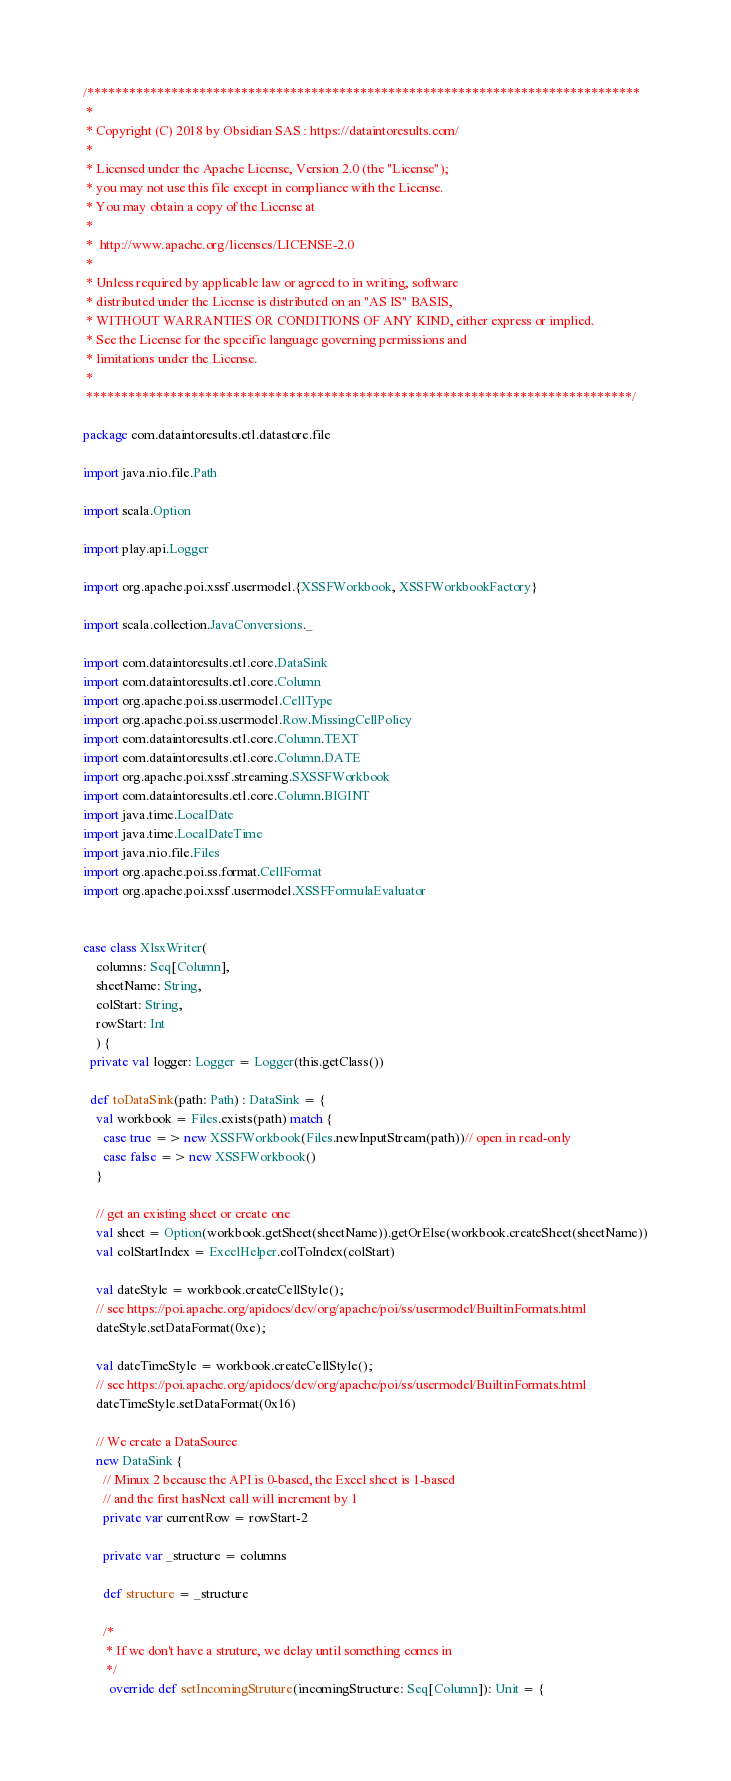Convert code to text. <code><loc_0><loc_0><loc_500><loc_500><_Scala_>/*******************************************************************************
 *
 * Copyright (C) 2018 by Obsidian SAS : https://dataintoresults.com/
 *
 * Licensed under the Apache License, Version 2.0 (the "License");
 * you may not use this file except in compliance with the License.
 * You may obtain a copy of the License at
 *
 *  http://www.apache.org/licenses/LICENSE-2.0
 *
 * Unless required by applicable law or agreed to in writing, software
 * distributed under the License is distributed on an "AS IS" BASIS,
 * WITHOUT WARRANTIES OR CONDITIONS OF ANY KIND, either express or implied.
 * See the License for the specific language governing permissions and
 * limitations under the License.
 *
 ******************************************************************************/

package com.dataintoresults.etl.datastore.file

import java.nio.file.Path

import scala.Option

import play.api.Logger

import org.apache.poi.xssf.usermodel.{XSSFWorkbook, XSSFWorkbookFactory}

import scala.collection.JavaConversions._

import com.dataintoresults.etl.core.DataSink
import com.dataintoresults.etl.core.Column
import org.apache.poi.ss.usermodel.CellType
import org.apache.poi.ss.usermodel.Row.MissingCellPolicy
import com.dataintoresults.etl.core.Column.TEXT
import com.dataintoresults.etl.core.Column.DATE
import org.apache.poi.xssf.streaming.SXSSFWorkbook
import com.dataintoresults.etl.core.Column.BIGINT
import java.time.LocalDate
import java.time.LocalDateTime
import java.nio.file.Files
import org.apache.poi.ss.format.CellFormat
import org.apache.poi.xssf.usermodel.XSSFFormulaEvaluator


case class XlsxWriter(
    columns: Seq[Column],
    sheetName: String,
    colStart: String,
    rowStart: Int
    ) {      
  private val logger: Logger = Logger(this.getClass())

  def toDataSink(path: Path) : DataSink = {
    val workbook = Files.exists(path) match {
      case true => new XSSFWorkbook(Files.newInputStream(path))// open in read-only
      case false => new XSSFWorkbook()
    }
    
    // get an existing sheet or create one
    val sheet = Option(workbook.getSheet(sheetName)).getOrElse(workbook.createSheet(sheetName))
    val colStartIndex = ExcelHelper.colToIndex(colStart)

    val dateStyle = workbook.createCellStyle();
    // see https://poi.apache.org/apidocs/dev/org/apache/poi/ss/usermodel/BuiltinFormats.html
    dateStyle.setDataFormat(0xe);

    val dateTimeStyle = workbook.createCellStyle();
    // see https://poi.apache.org/apidocs/dev/org/apache/poi/ss/usermodel/BuiltinFormats.html
    dateTimeStyle.setDataFormat(0x16)

    // We create a DataSource
    new DataSink {
      // Minux 2 because the API is 0-based, the Excel sheet is 1-based
      // and the first hasNext call will increment by 1
      private var currentRow = rowStart-2
      
      private var _structure = columns

      def structure = _structure

      /*
       * If we don't have a struture, we delay until something comes in
       */
	    override def setIncomingStruture(incomingStructure: Seq[Column]): Unit = {</code> 